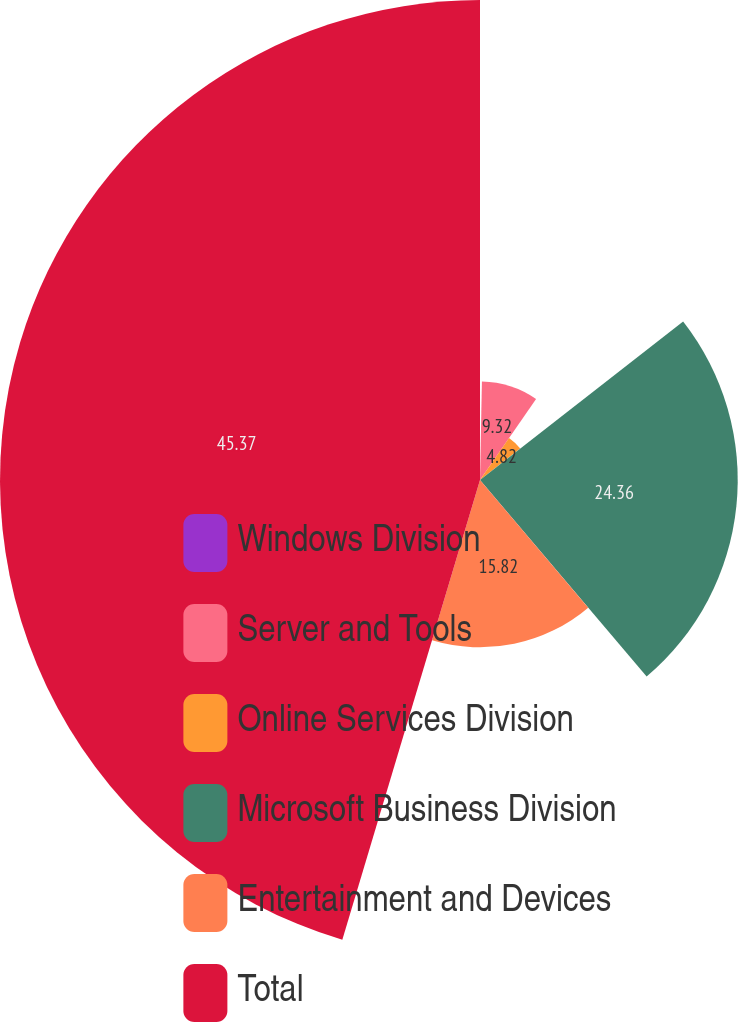Convert chart to OTSL. <chart><loc_0><loc_0><loc_500><loc_500><pie_chart><fcel>Windows Division<fcel>Server and Tools<fcel>Online Services Division<fcel>Microsoft Business Division<fcel>Entertainment and Devices<fcel>Total<nl><fcel>0.31%<fcel>9.32%<fcel>4.82%<fcel>24.36%<fcel>15.82%<fcel>45.37%<nl></chart> 